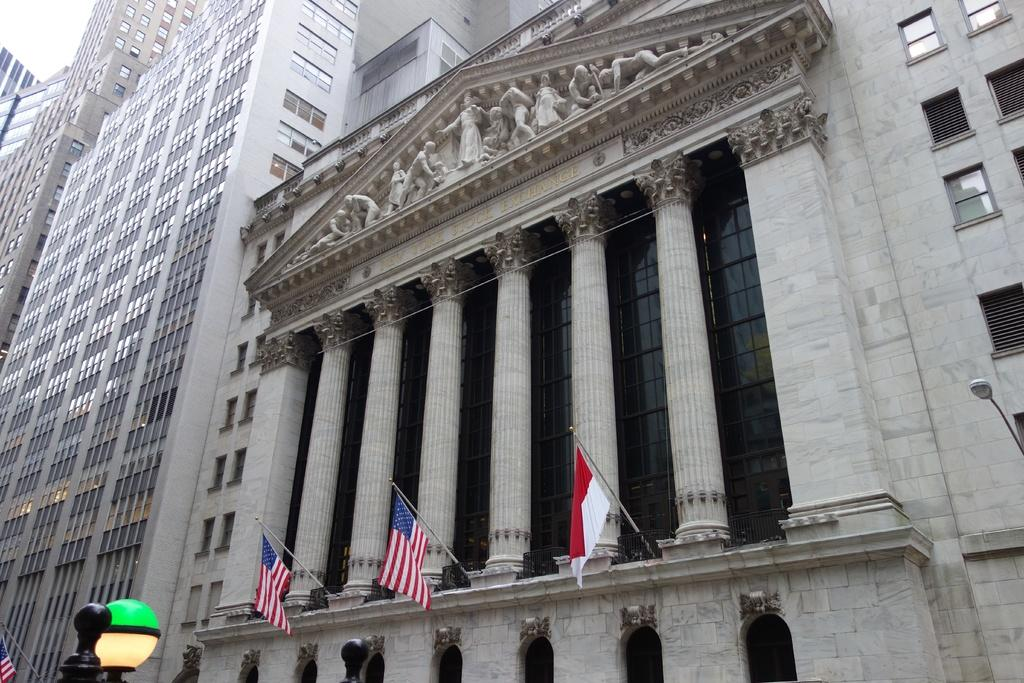What type of structures can be seen in the image? There are buildings in the image. What additional elements are present in the image? There are flags and pole lights in the image. What type of cemetery can be seen in the image? There is no cemetery present in the image; it features buildings, flags, and pole lights. What type of airport can be seen in the image? There is no airport present in the image; it features buildings, flags, and pole lights. 